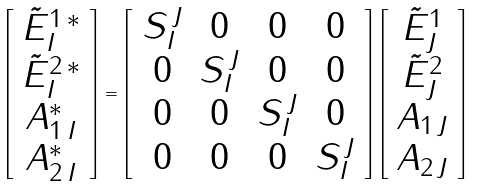Convert formula to latex. <formula><loc_0><loc_0><loc_500><loc_500>\left [ \begin{array} { c } { \tilde { E } } ^ { 1 \, * } _ { I } \\ { \tilde { E } } ^ { 2 \, * } _ { I } \\ A ^ { * } _ { 1 \, I } \\ A ^ { * } _ { 2 \, I } \end{array} \right ] = \left [ \begin{array} { c c c c } S _ { I } ^ { \, J } & 0 & 0 & 0 \\ 0 & S _ { I } ^ { \, J } & 0 & 0 \\ 0 & 0 & S _ { I } ^ { \, J } & 0 \\ 0 & 0 & 0 & S _ { I } ^ { \, J } \end{array} \right ] \left [ \begin{array} { c } { \tilde { E } } ^ { 1 } _ { J } \\ { \tilde { E } } ^ { 2 } _ { J } \\ A _ { 1 \, J } \\ A _ { 2 \, J } \end{array} \right ]</formula> 